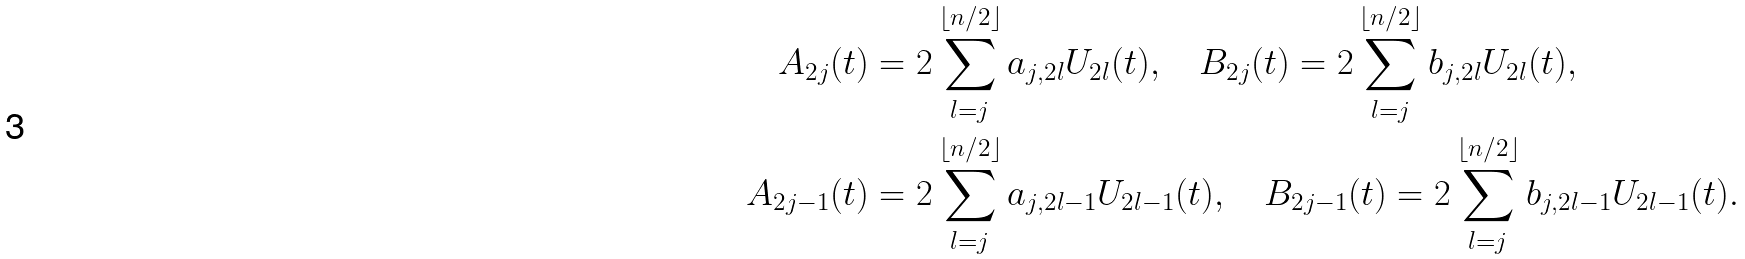Convert formula to latex. <formula><loc_0><loc_0><loc_500><loc_500>A _ { 2 j } ( t ) & = 2 \sum _ { l = j } ^ { \lfloor n / 2 \rfloor } a _ { j , 2 l } U _ { 2 l } ( t ) , \quad B _ { 2 j } ( t ) = 2 \sum _ { l = j } ^ { \lfloor n / 2 \rfloor } b _ { j , 2 l } U _ { 2 l } ( t ) , \\ A _ { 2 j - 1 } ( t ) & = 2 \sum _ { l = j } ^ { \lfloor n / 2 \rfloor } a _ { j , 2 l - 1 } U _ { 2 l - 1 } ( t ) , \quad B _ { 2 j - 1 } ( t ) = 2 \sum _ { l = j } ^ { \lfloor n / 2 \rfloor } b _ { j , 2 l - 1 } U _ { 2 l - 1 } ( t ) .</formula> 